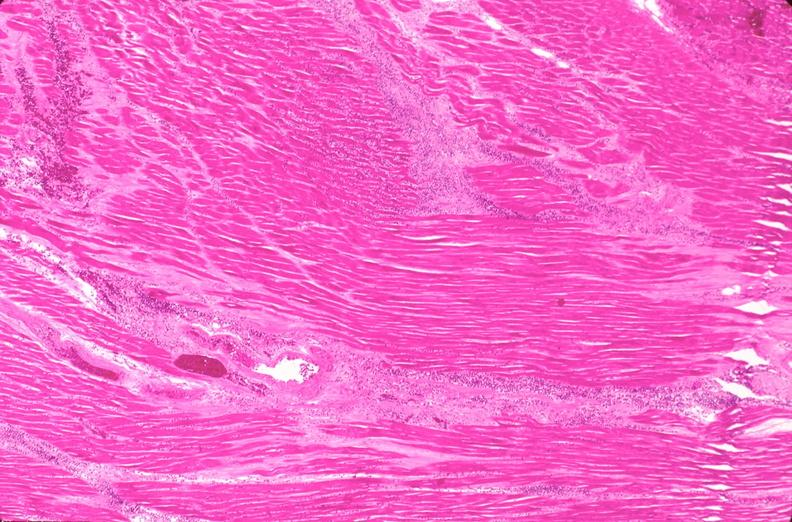where is this in?
Answer the question using a single word or phrase. In vasculature 